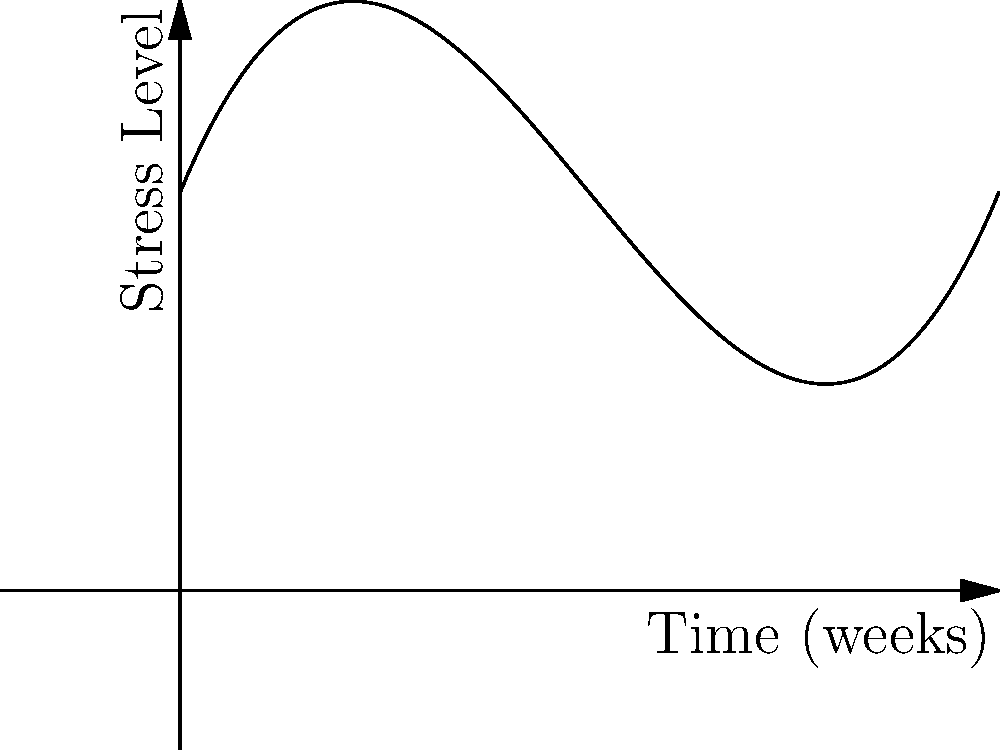The graph represents a patient's stress levels over time during therapy. Which point on the curve indicates the most effective period of stress reduction, and what does this suggest about the therapy process? To answer this question, we need to analyze the polynomial curve and its key points:

1. Point A (around week 2): The stress level is initially increasing, indicating the beginning of therapy where the patient might be confronting difficult issues.

2. Point B (around week 5): This is the lowest point on the curve, representing the minimum stress level. The steep decline from A to B suggests a period of significant stress reduction.

3. Point C (around week 8): The stress level has increased again, but not to the initial levels.

The most effective period of stress reduction is between points A and B, with point B representing the lowest stress level.

This pattern suggests:
1. Initial therapy sessions may temporarily increase stress as the patient confronts issues.
2. There's a "sweet spot" (around week 5) where therapy seems most effective in reducing stress.
3. Stress levels may rise again later, possibly due to new challenges or reduced therapy intensity.

The effectiveness of therapy isn't always linear, and some increase in stress after the low point is normal and doesn't necessarily indicate failure of the treatment.
Answer: Point B, suggesting therapy is most effective around week 5 but requires ongoing management. 